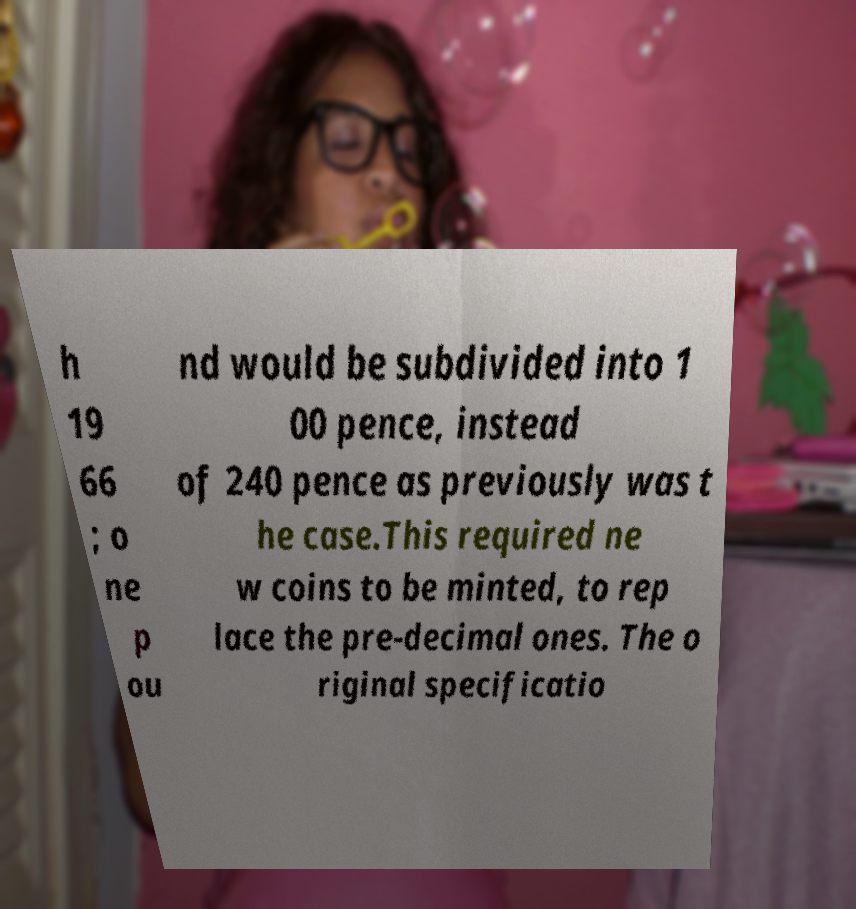Can you read and provide the text displayed in the image?This photo seems to have some interesting text. Can you extract and type it out for me? h 19 66 ; o ne p ou nd would be subdivided into 1 00 pence, instead of 240 pence as previously was t he case.This required ne w coins to be minted, to rep lace the pre-decimal ones. The o riginal specificatio 